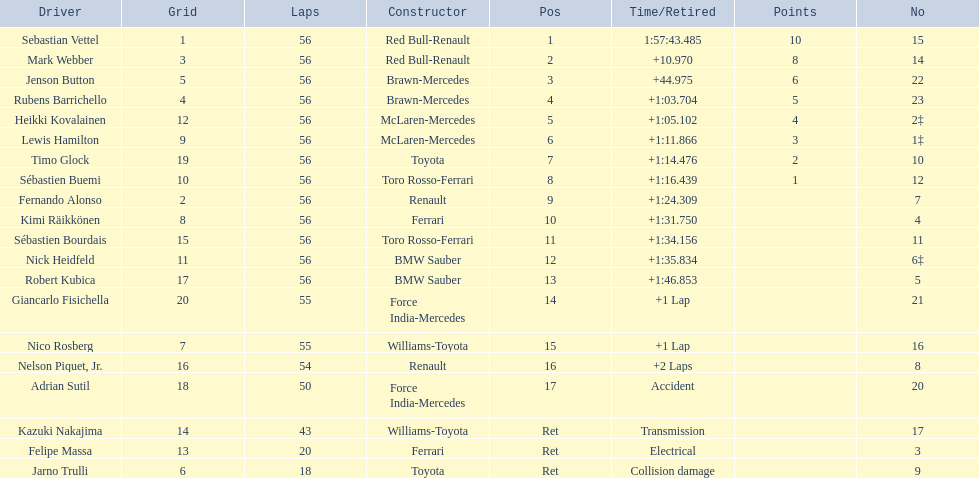Who were all the drivers? Sebastian Vettel, Mark Webber, Jenson Button, Rubens Barrichello, Heikki Kovalainen, Lewis Hamilton, Timo Glock, Sébastien Buemi, Fernando Alonso, Kimi Räikkönen, Sébastien Bourdais, Nick Heidfeld, Robert Kubica, Giancarlo Fisichella, Nico Rosberg, Nelson Piquet, Jr., Adrian Sutil, Kazuki Nakajima, Felipe Massa, Jarno Trulli. Which of these didn't have ferrari as a constructor? Sebastian Vettel, Mark Webber, Jenson Button, Rubens Barrichello, Heikki Kovalainen, Lewis Hamilton, Timo Glock, Sébastien Buemi, Fernando Alonso, Sébastien Bourdais, Nick Heidfeld, Robert Kubica, Giancarlo Fisichella, Nico Rosberg, Nelson Piquet, Jr., Adrian Sutil, Kazuki Nakajima, Jarno Trulli. Which of these was in first place? Sebastian Vettel. 